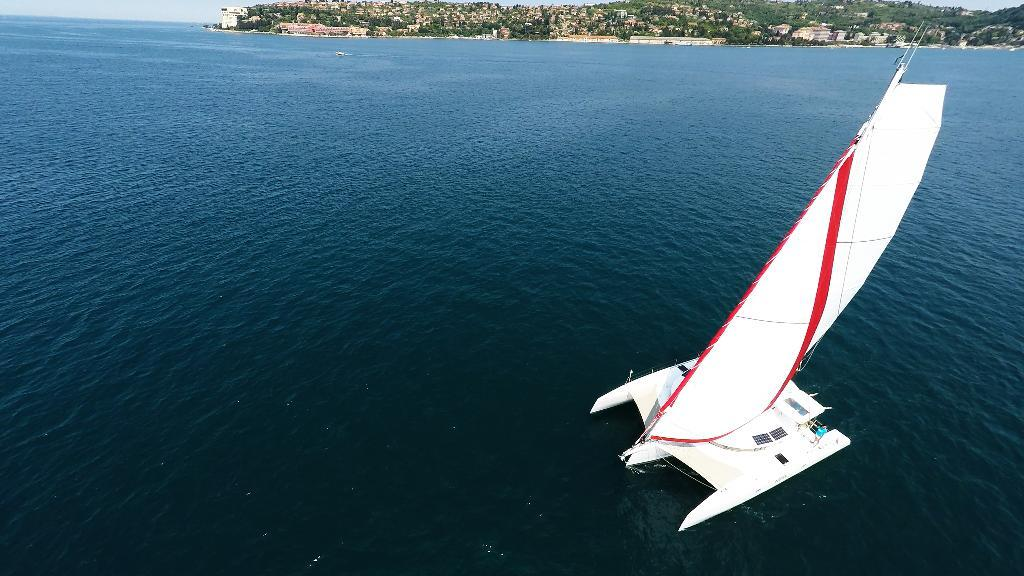What is the main subject of the image? The main subject of the image is a boat. Where is the boat located? The boat is on the water. What else can be seen in the image besides the boat? There are buildings, trees, and the sky visible in the image. What type of cushion is being used to paddle the boat in the image? There is no cushion present in the image, and the boat is not being paddled. 